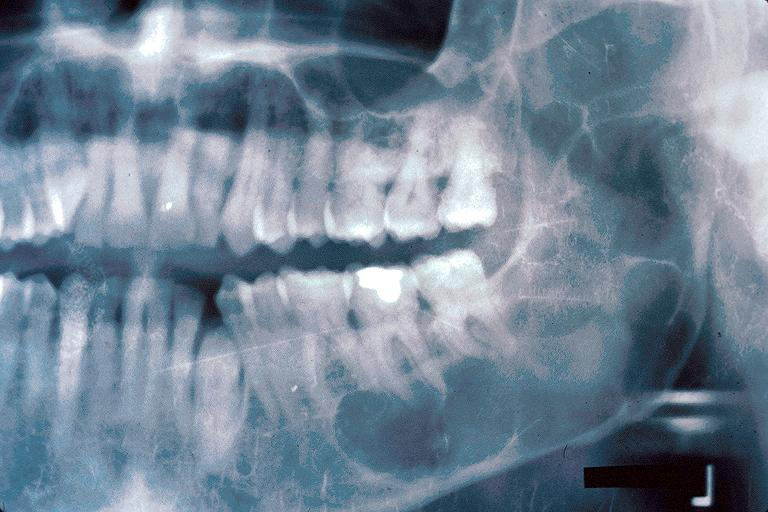s oral present?
Answer the question using a single word or phrase. Yes 